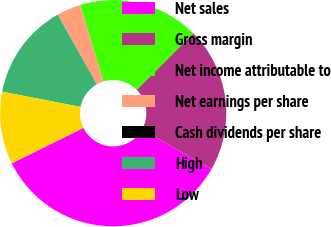Convert chart to OTSL. <chart><loc_0><loc_0><loc_500><loc_500><pie_chart><fcel>Net sales<fcel>Gross margin<fcel>Net income attributable to<fcel>Net earnings per share<fcel>Cash dividends per share<fcel>High<fcel>Low<nl><fcel>34.48%<fcel>20.69%<fcel>17.24%<fcel>3.45%<fcel>0.0%<fcel>13.79%<fcel>10.35%<nl></chart> 